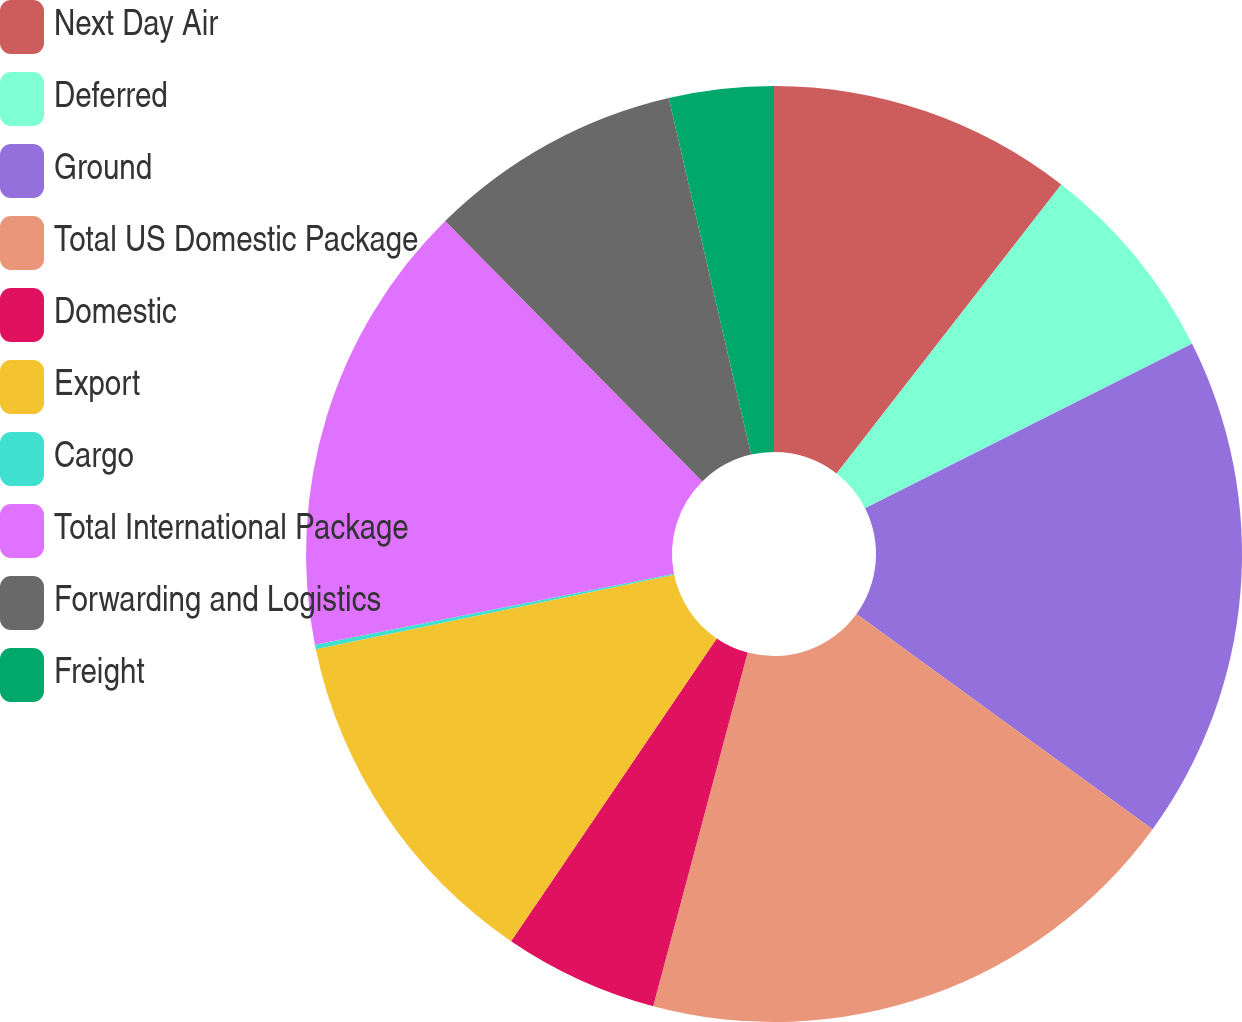Convert chart to OTSL. <chart><loc_0><loc_0><loc_500><loc_500><pie_chart><fcel>Next Day Air<fcel>Deferred<fcel>Ground<fcel>Total US Domestic Package<fcel>Domestic<fcel>Export<fcel>Cargo<fcel>Total International Package<fcel>Forwarding and Logistics<fcel>Freight<nl><fcel>10.52%<fcel>7.06%<fcel>17.42%<fcel>19.15%<fcel>5.34%<fcel>12.24%<fcel>0.16%<fcel>15.7%<fcel>8.79%<fcel>3.61%<nl></chart> 